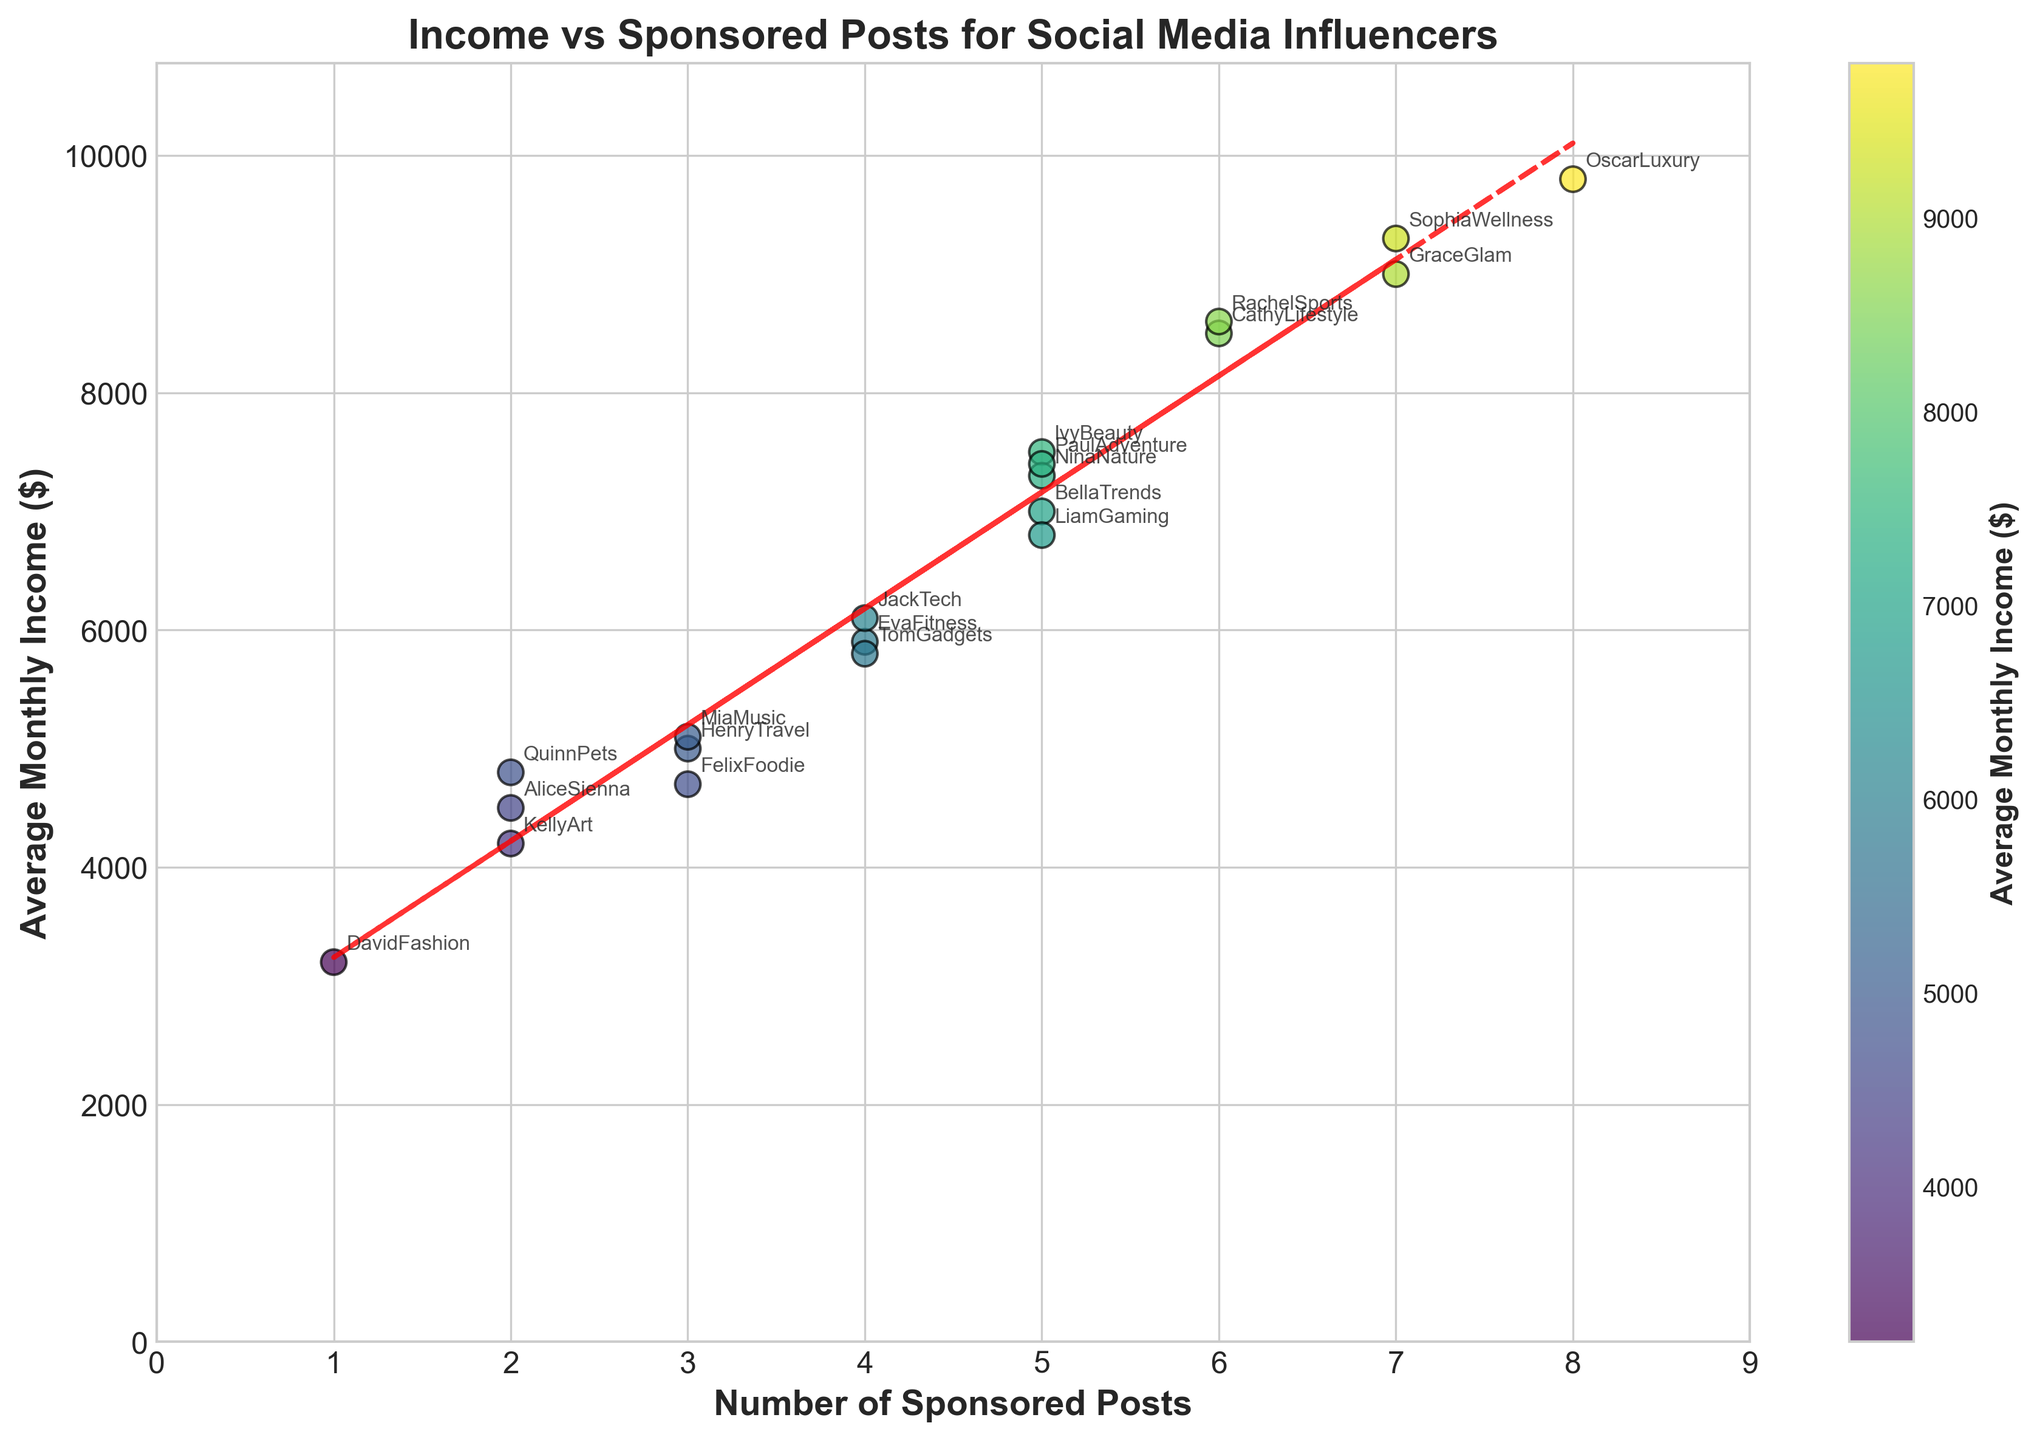What is the title of the scatter plot? The title of the scatter plot is usually at the top of the figure, showing the main topic of the graph.
Answer: Income vs Sponsored Posts for Social Media Influencers How many data points are in the scatter plot? The number of data points can be determined by counting the individual markers on the plot.
Answer: 20 What is the average monthly income of the influencer with the highest number of sponsored posts? The influencer with the highest number of sponsored posts (8) is OscarLuxury, who has an average monthly income of $9800.
Answer: $9800 Which influencer has the lowest average monthly income? By looking at the vertical axis and finding the lowest point, the influencer DavidFashion has an average monthly income of $3200.
Answer: DavidFashion Who has more sponsored posts, EvaFitness or JackTech? JackTech has 4 sponsored posts, while EvaFitness also has 4 sponsored posts. Therefore, both have the same number of sponsored posts.
Answer: Both have 4 What is the average monthly income of influencers with exactly 3 sponsored posts? The influencers with 3 sponsored posts are FelixFoodie, HenryTravel, MiaMusic. Summing their incomes (4700 + 5000 + 5100) and averaging: (4700 + 5000 + 5100) / 3 = 4967.
Answer: $4967 Are there any influencers with the same number of sponsored posts and different monthly incomes? Yes, for example, BellaTrends and IvyBeauty both have 5 sponsored posts but with incomes $7000 and $7500 respectively.
Answer: Yes What is the trend shown by the red dashed line in the scatter plot? The red dashed line is a trend line, which indicates that as the number of sponsored posts increases, the average monthly income generally increases as well.
Answer: Income increases with more sponsored posts Compare the average monthly incomes of LiamGaming and CathyLifestyle. Who earns more? LiamGaming has an average monthly income of $6800, whereas CathyLifestyle has $8500. Hence, CathyLifestyle earns more.
Answer: CathyLifestyle What is the range of average monthly incomes shown on the plot? The minimum average monthly income is $3200 (DavidFashion) and the maximum is $9800 (OscarLuxury). Hence, the range is $9800 - $3200 = $6600.
Answer: $6600 